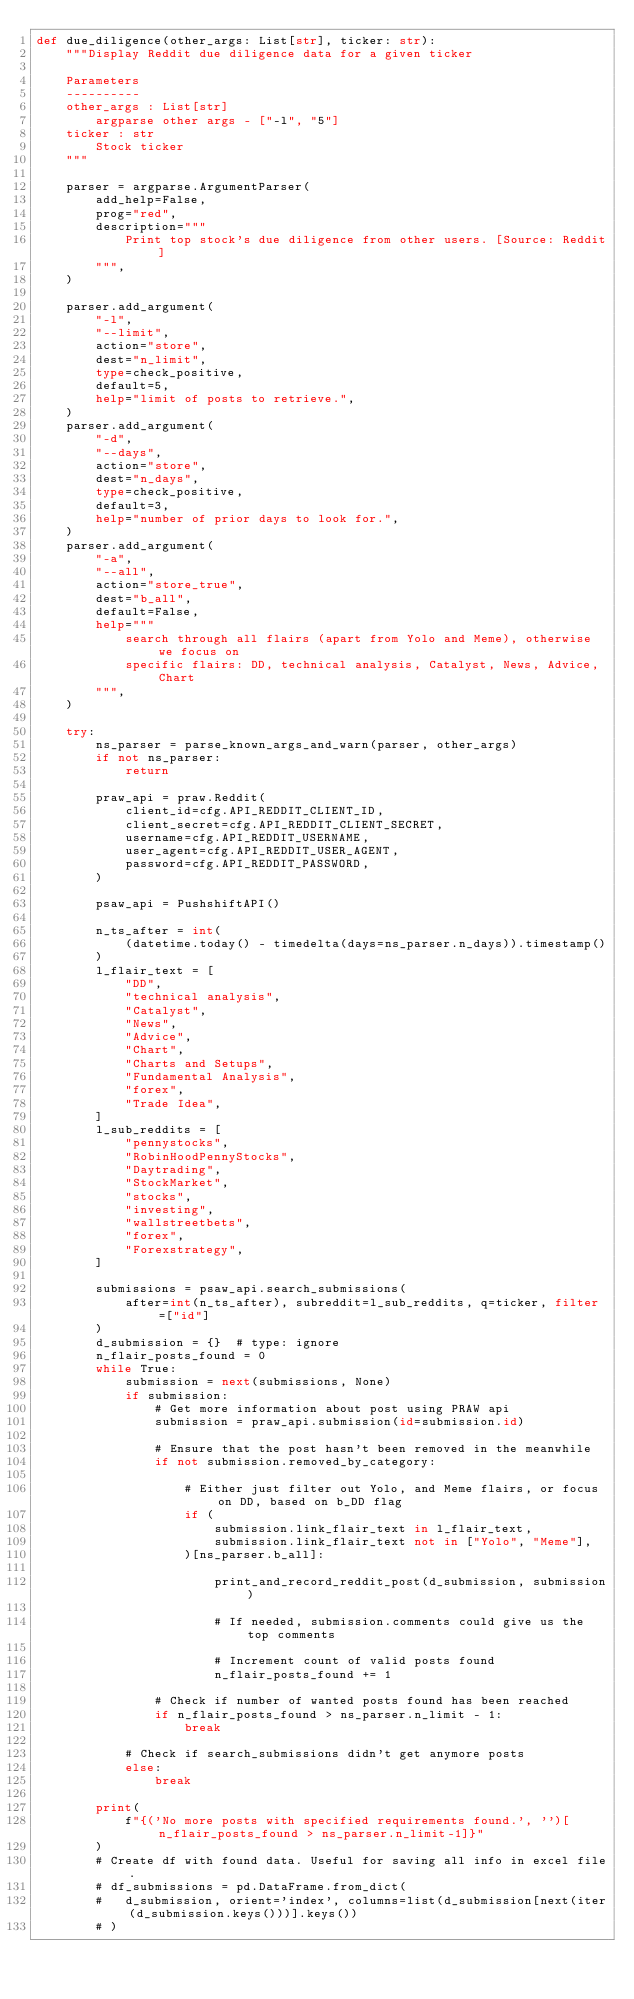<code> <loc_0><loc_0><loc_500><loc_500><_Python_>def due_diligence(other_args: List[str], ticker: str):
    """Display Reddit due diligence data for a given ticker

    Parameters
    ----------
    other_args : List[str]
        argparse other args - ["-l", "5"]
    ticker : str
        Stock ticker
    """

    parser = argparse.ArgumentParser(
        add_help=False,
        prog="red",
        description="""
            Print top stock's due diligence from other users. [Source: Reddit]
        """,
    )

    parser.add_argument(
        "-l",
        "--limit",
        action="store",
        dest="n_limit",
        type=check_positive,
        default=5,
        help="limit of posts to retrieve.",
    )
    parser.add_argument(
        "-d",
        "--days",
        action="store",
        dest="n_days",
        type=check_positive,
        default=3,
        help="number of prior days to look for.",
    )
    parser.add_argument(
        "-a",
        "--all",
        action="store_true",
        dest="b_all",
        default=False,
        help="""
            search through all flairs (apart from Yolo and Meme), otherwise we focus on
            specific flairs: DD, technical analysis, Catalyst, News, Advice, Chart
        """,
    )

    try:
        ns_parser = parse_known_args_and_warn(parser, other_args)
        if not ns_parser:
            return

        praw_api = praw.Reddit(
            client_id=cfg.API_REDDIT_CLIENT_ID,
            client_secret=cfg.API_REDDIT_CLIENT_SECRET,
            username=cfg.API_REDDIT_USERNAME,
            user_agent=cfg.API_REDDIT_USER_AGENT,
            password=cfg.API_REDDIT_PASSWORD,
        )

        psaw_api = PushshiftAPI()

        n_ts_after = int(
            (datetime.today() - timedelta(days=ns_parser.n_days)).timestamp()
        )
        l_flair_text = [
            "DD",
            "technical analysis",
            "Catalyst",
            "News",
            "Advice",
            "Chart",
            "Charts and Setups",
            "Fundamental Analysis",
            "forex",
            "Trade Idea",
        ]
        l_sub_reddits = [
            "pennystocks",
            "RobinHoodPennyStocks",
            "Daytrading",
            "StockMarket",
            "stocks",
            "investing",
            "wallstreetbets",
            "forex",
            "Forexstrategy",
        ]

        submissions = psaw_api.search_submissions(
            after=int(n_ts_after), subreddit=l_sub_reddits, q=ticker, filter=["id"]
        )
        d_submission = {}  # type: ignore
        n_flair_posts_found = 0
        while True:
            submission = next(submissions, None)
            if submission:
                # Get more information about post using PRAW api
                submission = praw_api.submission(id=submission.id)

                # Ensure that the post hasn't been removed in the meanwhile
                if not submission.removed_by_category:

                    # Either just filter out Yolo, and Meme flairs, or focus on DD, based on b_DD flag
                    if (
                        submission.link_flair_text in l_flair_text,
                        submission.link_flair_text not in ["Yolo", "Meme"],
                    )[ns_parser.b_all]:

                        print_and_record_reddit_post(d_submission, submission)

                        # If needed, submission.comments could give us the top comments

                        # Increment count of valid posts found
                        n_flair_posts_found += 1

                # Check if number of wanted posts found has been reached
                if n_flair_posts_found > ns_parser.n_limit - 1:
                    break

            # Check if search_submissions didn't get anymore posts
            else:
                break

        print(
            f"{('No more posts with specified requirements found.', '')[n_flair_posts_found > ns_parser.n_limit-1]}"
        )
        # Create df with found data. Useful for saving all info in excel file.
        # df_submissions = pd.DataFrame.from_dict(
        #   d_submission, orient='index', columns=list(d_submission[next(iter(d_submission.keys()))].keys())
        # )</code> 